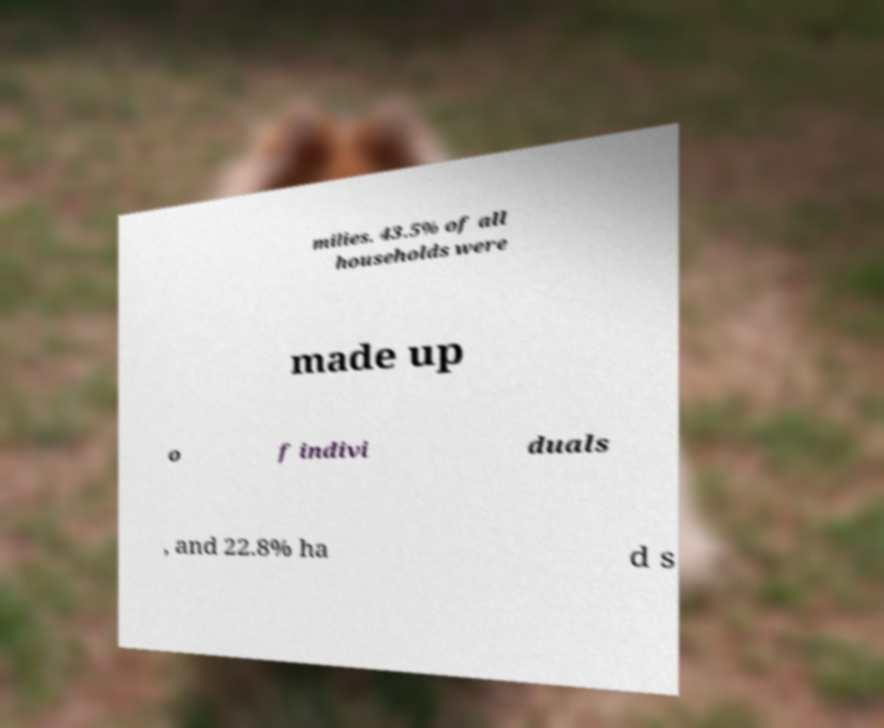Could you assist in decoding the text presented in this image and type it out clearly? milies. 43.5% of all households were made up o f indivi duals , and 22.8% ha d s 